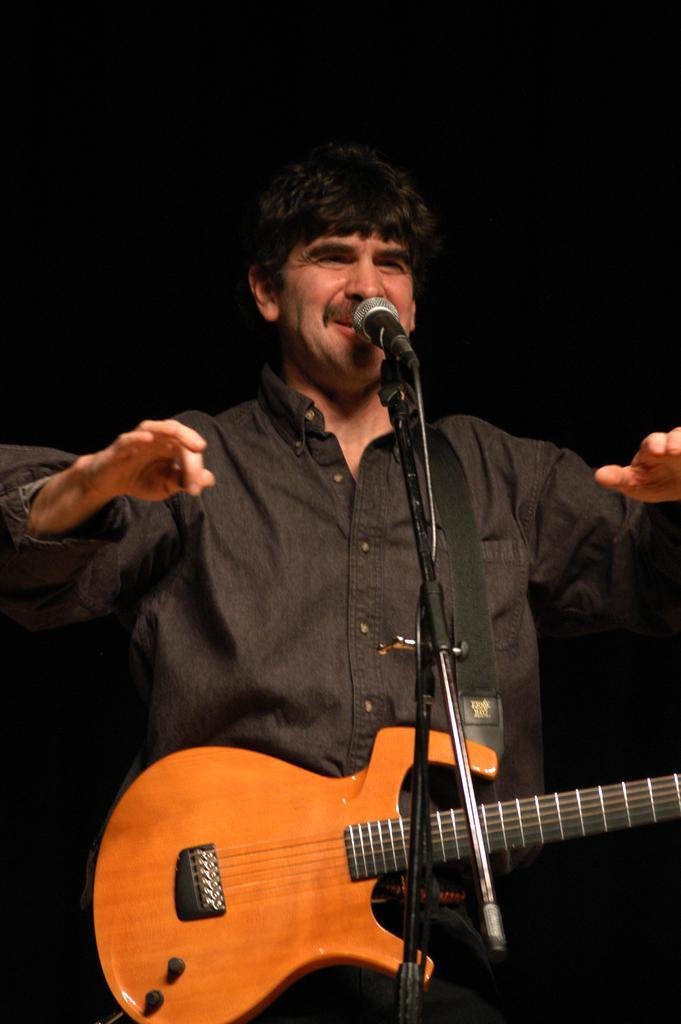Describe this image in one or two sentences. In this image I can see a man wearing a black shirt and standing. He is singing a song and holding a guitar. This is mike with the mike stand. 